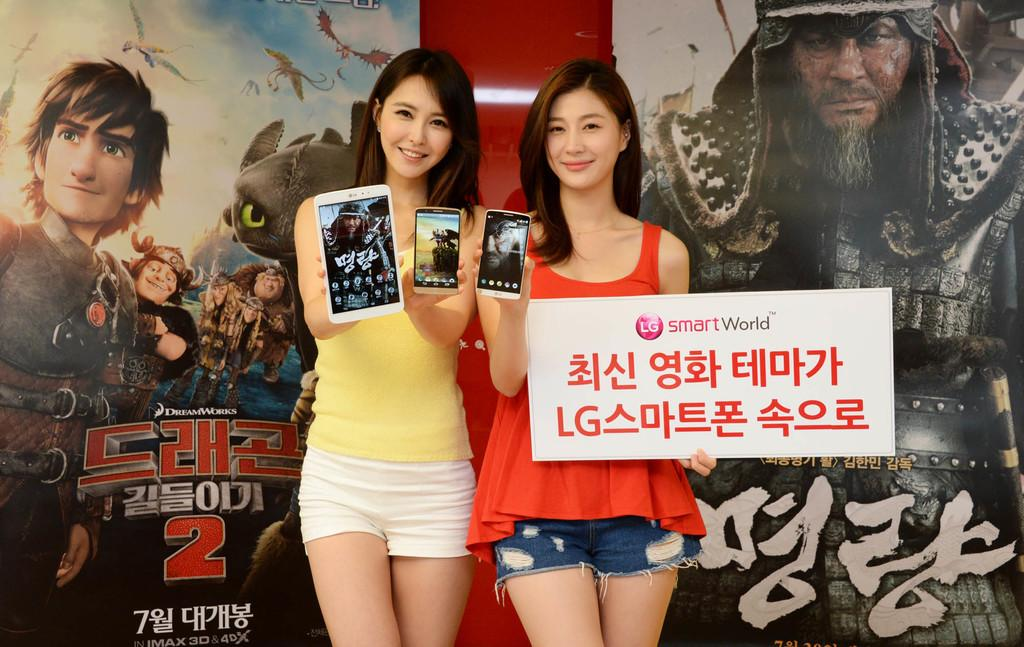How many women are in the image? There are two women in the image. What are the women doing in the image? The women are standing and holding mobile phones in their hands. What else are the women holding in their hands? The women are also holding a name board in their hands. What can be seen in the background of the image? There is a wall in the background of the image, and posters of cartoons are on the wall. How many babies are crawling on the floor in the image? There are no babies present in the image. What type of art is displayed on the wall in the image? The wall in the image has posters of cartoons, which are not considered traditional art. 